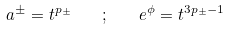<formula> <loc_0><loc_0><loc_500><loc_500>a ^ { \pm } = t ^ { p _ { \pm } } \quad ; \quad e ^ { \phi } = t ^ { 3 p _ { \pm } - 1 }</formula> 